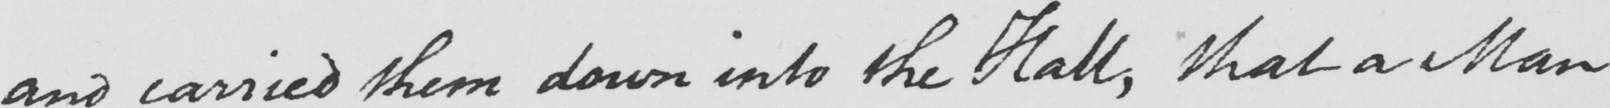Can you read and transcribe this handwriting? and carried them down into the Hall , that a Man 